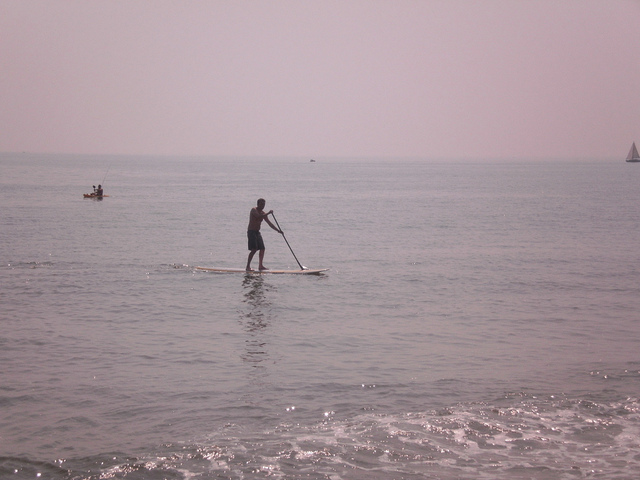<image>What kind of animals are flying above the person? It is ambiguous what kind of animals are flying above the person. It could be birds or none. What kind of animals are flying above the person? I am not sure what kinds of animals are flying above the person. It can be birds or none. 